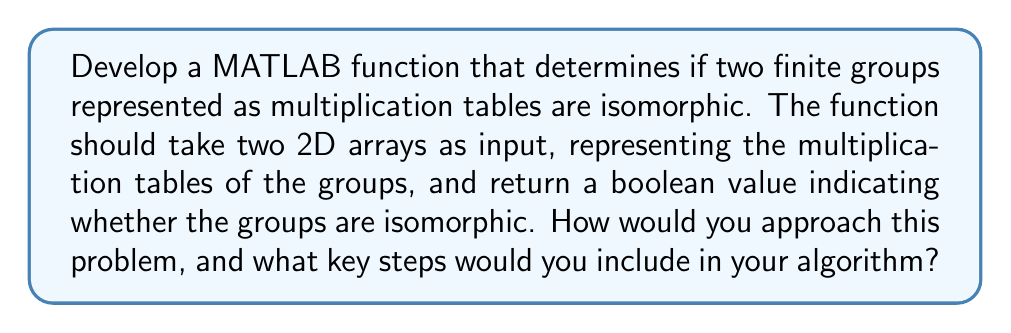Can you solve this math problem? To develop a MATLAB function that determines if two finite groups are isomorphic based on their multiplication tables, we can follow these steps:

1. Input validation:
   - Ensure both input arrays are square matrices of the same size.
   - Check if the multiplication tables represent valid groups (closure, associativity, identity, and inverses).

2. Compare group orders:
   - If the sizes of the multiplication tables are different, the groups cannot be isomorphic.

3. Generate all possible bijections:
   - Create all possible one-to-one mappings between the elements of the two groups.
   - For a group of order $n$, there are $n!$ possible bijections.

4. Check each bijection:
   - For each bijection $f$, verify if it preserves the group operation:
     $$f(a * b) = f(a) \circ f(b)$$
   where $*$ is the operation in the first group and $\circ$ is the operation in the second group.

5. Implement the algorithm in MATLAB:

```matlab
function isIsomorphic = checkIsomorphism(G1, G2)
    % Input validation
    [n1, m1] = size(G1);
    [n2, m2] = size(G2);
    if n1 ~= m1 || n2 ~= m2 || n1 ~= n2
        isIsomorphic = false;
        return;
    end
    
    n = n1;
    
    % Generate all possible permutations
    perms = perms(1:n);
    
    % Check each permutation
    for i = 1:size(perms, 1)
        f = perms(i, :);
        isValid = true;
        
        % Check if the mapping preserves the group operation
        for a = 1:n
            for b = 1:n
                if G2(f(a), f(b)) ~= f(G1(a, b))
                    isValid = false;
                    break;
                end
            end
            if ~isValid
                break;
            end
        end
        
        if isValid
            isIsomorphic = true;
            return;
        end
    end
    
    isIsomorphic = false;
end
```

This function takes two multiplication tables G1 and G2 as input and returns a boolean value indicating whether the groups are isomorphic.

Note: This algorithm has a time complexity of $O(n! \cdot n^2)$, where $n$ is the order of the groups. It becomes impractical for groups with large orders. For larger groups, more sophisticated algorithms using group-theoretic properties would be necessary.
Answer: The key steps to determine if two finite groups are isomorphic using their multiplication tables in MATLAB are:

1. Validate input matrices (same size, valid group properties)
2. Compare group orders
3. Generate all possible bijections (permutations)
4. Check if each bijection preserves the group operation
5. Return true if a valid isomorphism is found, false otherwise

The provided MATLAB function `checkIsomorphism` implements this algorithm. 